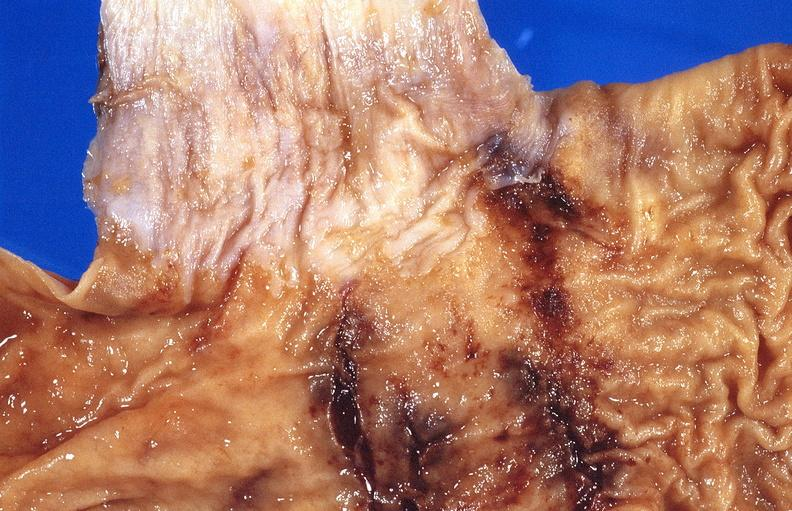what is present?
Answer the question using a single word or phrase. Gastrointestinal 